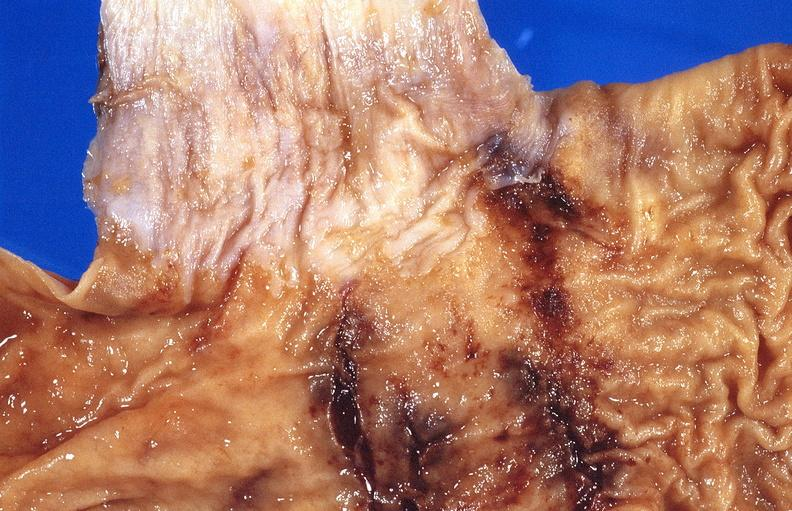what is present?
Answer the question using a single word or phrase. Gastrointestinal 